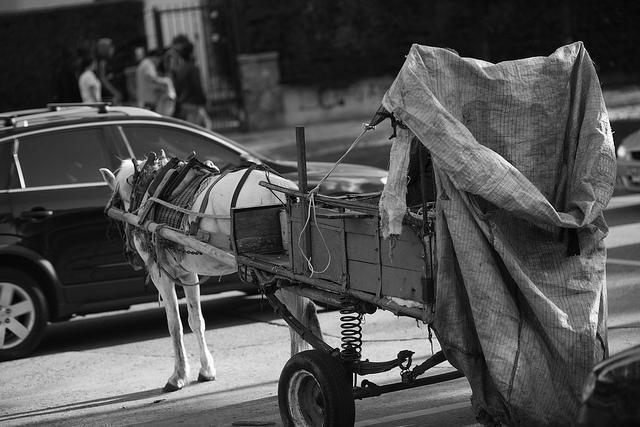Why is the animal that is hooked up to the cart doing?
Indicate the correct response by choosing from the four available options to answer the question.
Options: Racing, eating, waiting, drinking. Waiting. 